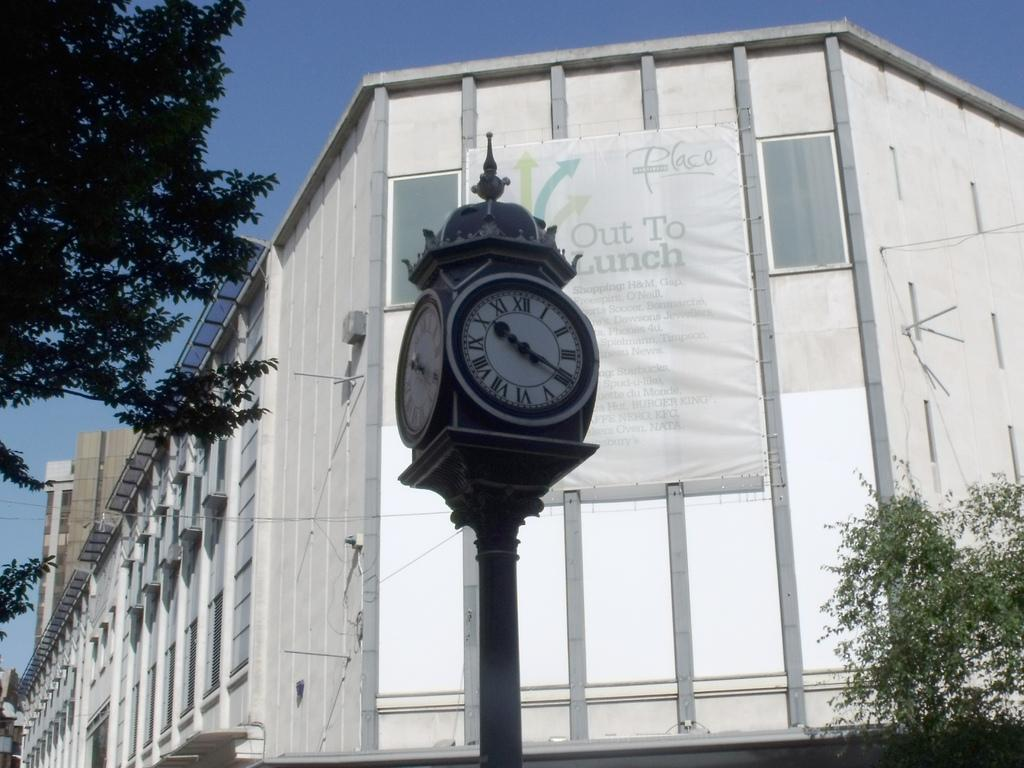Provide a one-sentence caption for the provided image. roman numeral clock outside in front of a big building. 